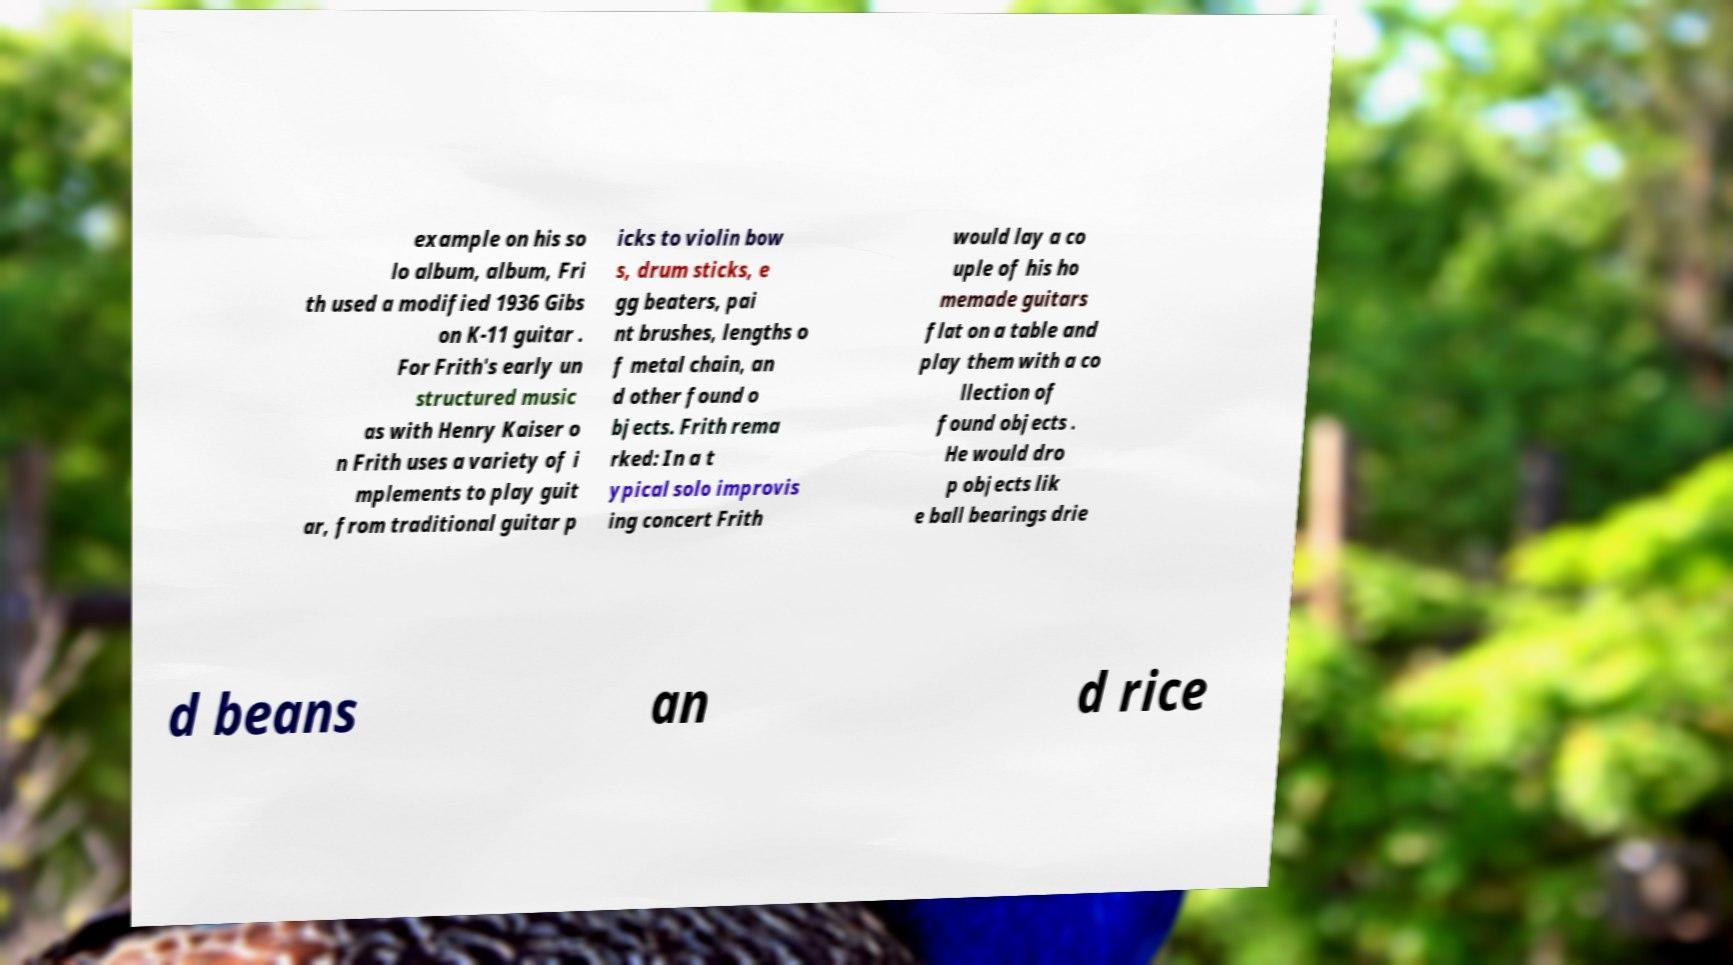Can you accurately transcribe the text from the provided image for me? example on his so lo album, album, Fri th used a modified 1936 Gibs on K-11 guitar . For Frith's early un structured music as with Henry Kaiser o n Frith uses a variety of i mplements to play guit ar, from traditional guitar p icks to violin bow s, drum sticks, e gg beaters, pai nt brushes, lengths o f metal chain, an d other found o bjects. Frith rema rked: In a t ypical solo improvis ing concert Frith would lay a co uple of his ho memade guitars flat on a table and play them with a co llection of found objects . He would dro p objects lik e ball bearings drie d beans an d rice 